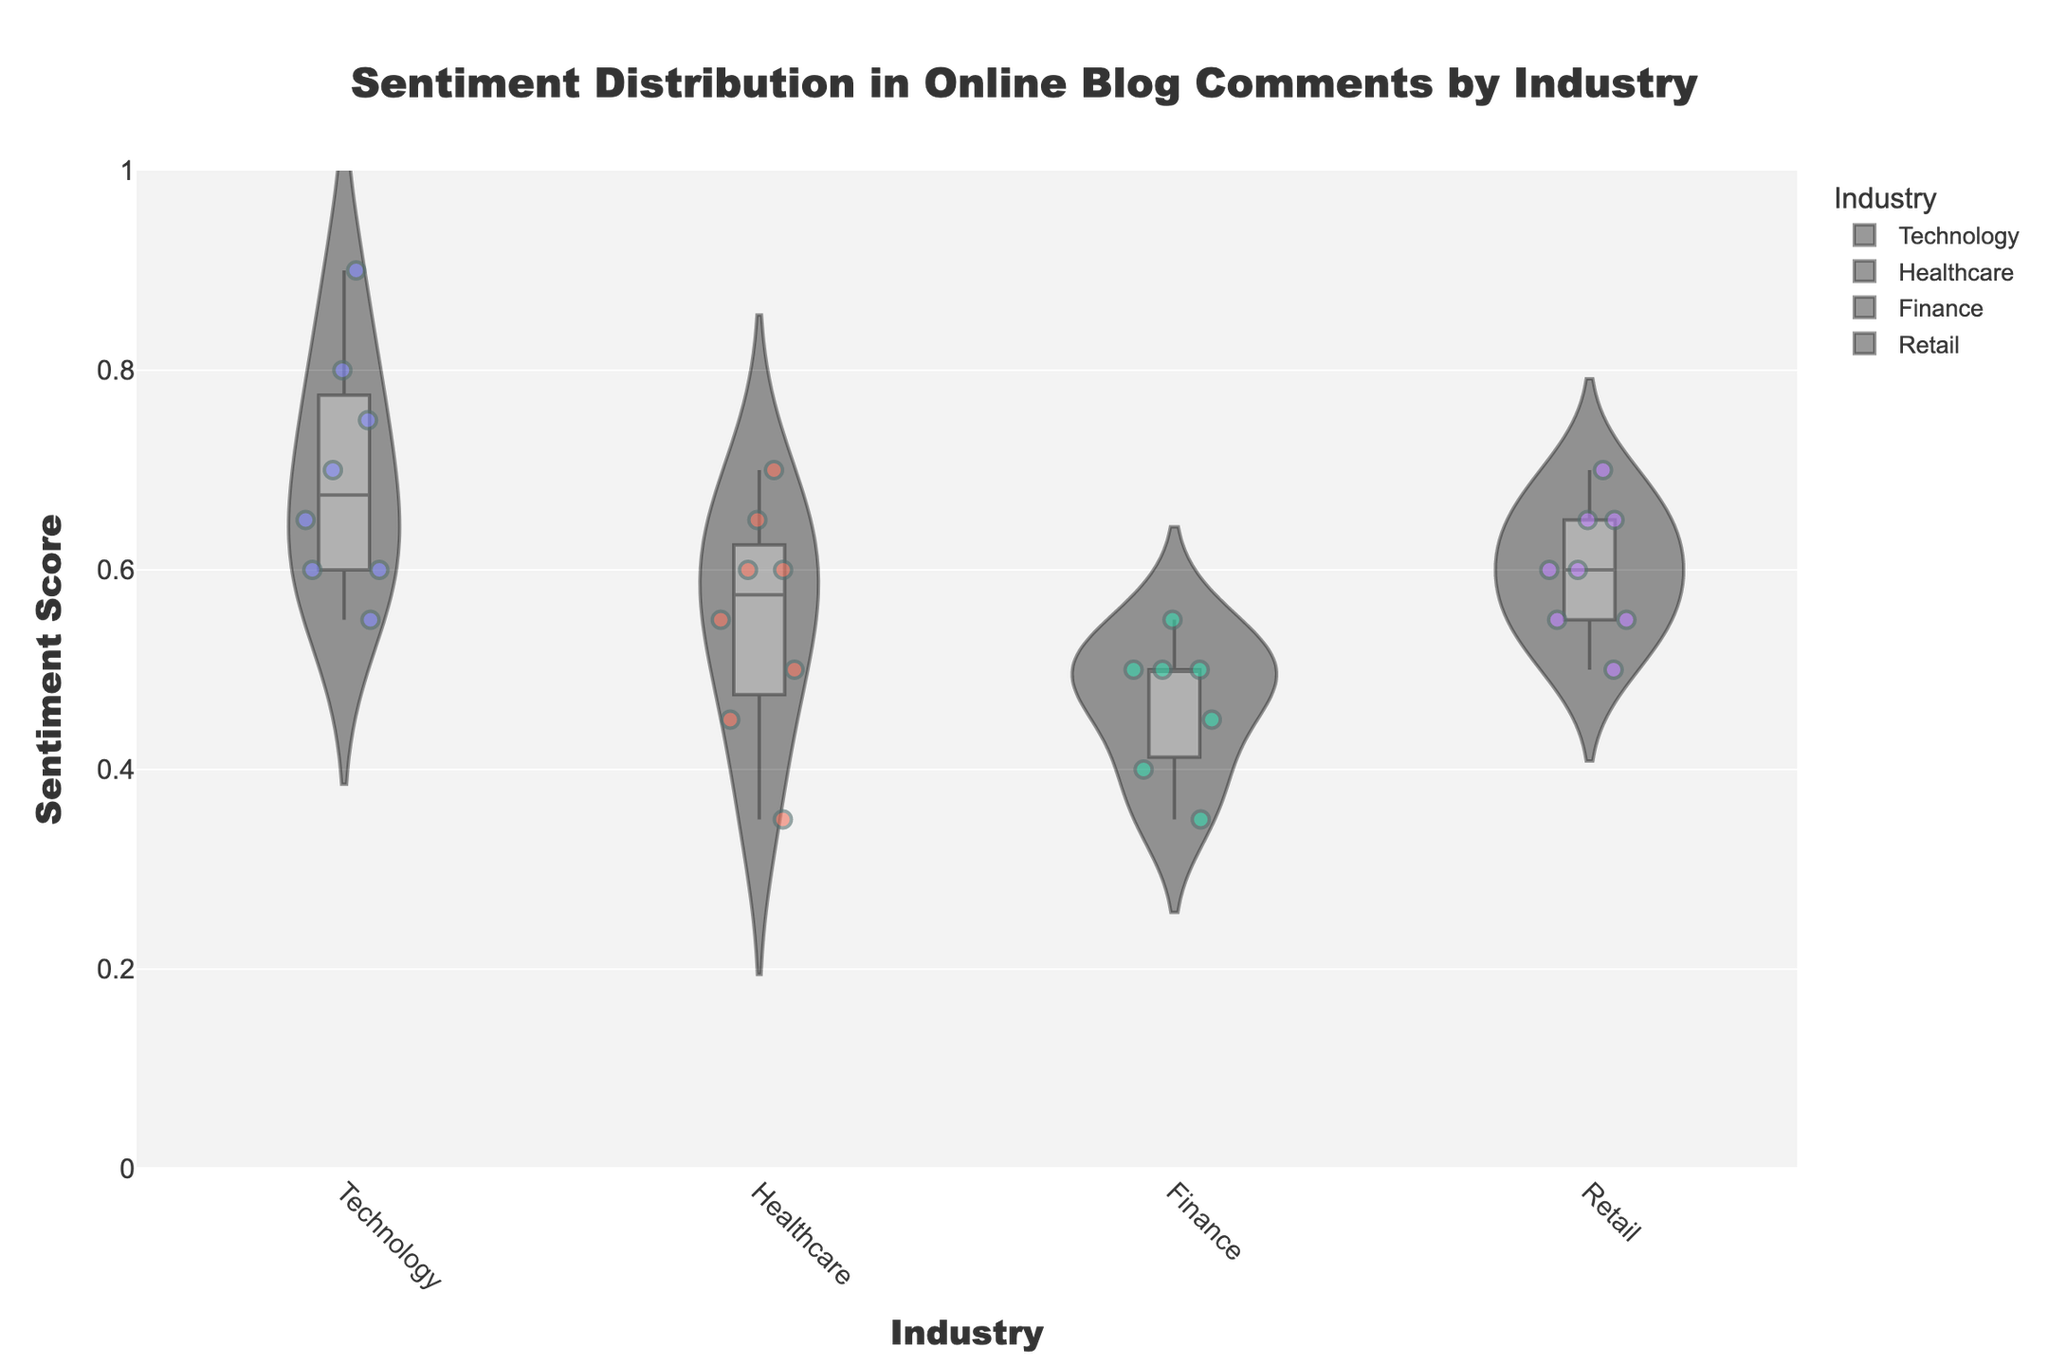What's the overall title of the plot? The title is centered at the top of the figure and states the main subject of the visualization, which is "Sentiment Distribution in Online Blog Comments by Industry".
Answer: Sentiment Distribution in Online Blog Comments by Industry Which industry has the majority of high sentiment scores? By observing the distribution of the sentiment scores, Technology shows a higher density of scores above 0.6 compared to other industries.
Answer: Technology How many industries are being compared in the figure? By counting the unique labels on the x-axis, there are four visible industry categories: Technology, Healthcare, Finance, and Retail.
Answer: Four Within the Healthcare industry, which company has the lowest sentiment score? Points on the violin plot indicate individual sentiment scores. The lowest point within the Healthcare violin plot belongs to Johnson & Johnson.
Answer: Johnson & Johnson What's the range of sentiment scores in the Finance industry? The Finance industry's range can be determined by looking at the spread of the violin plot: it spans from the lowest marker at 0.35 to the highest at 0.55.
Answer: 0.35 to 0.55 Which industry shows the least variability in sentiment scores? The width and spread of the violins help identify variability. Finance has the narrowest and shortest spread, indicating the least variability.
Answer: Finance Do any industries have sentiment scores as low as zero? The y-axis range spans from 0 to 1, and none of the sentiment scores across the industries reach as low as zero, as evident in the absence of any points at the zero level.
Answer: No How does the sentiment score distribution of Amazon compare to Walmart? Amazon's distribution, shown in the Retail industry's violin plot, has clearly higher sentiment scores concentrated around 0.6-0.7, whereas Walmart's sentiment scores peak around 0.5-0.55, indicating Amazon's scores are generally higher.
Answer: Amazon's scores are generally higher Does the Technology industry have a tighter cluster of sentiment scores compared to the Healthcare industry? The width and shape of the violin plots indicate the density of scores. Technology shows a tighter cluster around high scores, whereas Healthcare has a wider, more spread-out range of sentiment scores.
Answer: Yes, Technology has a tighter cluster Between Technology and Retail, which has a wider range of sentiment scores? Comparing the vertical span of the violin plots, Technology ranges from approximately 0.55 to 0.9, while Retail ranges from around 0.5 to 0.7, making Technology's range wider.
Answer: Technology 